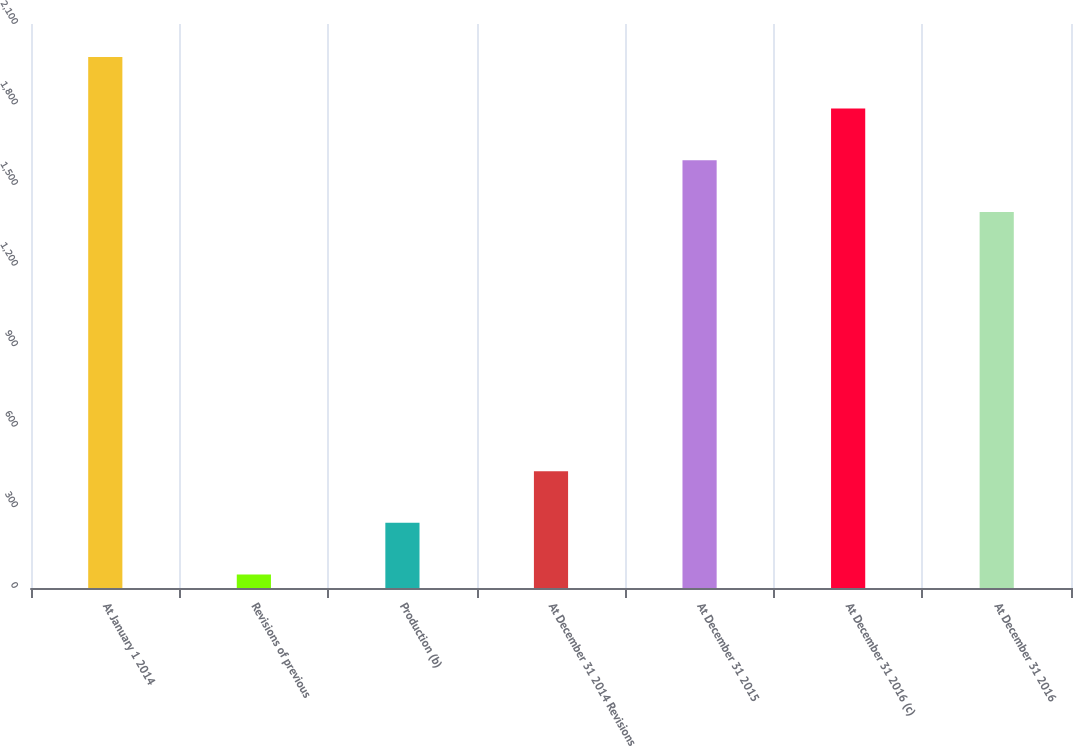Convert chart to OTSL. <chart><loc_0><loc_0><loc_500><loc_500><bar_chart><fcel>At January 1 2014<fcel>Revisions of previous<fcel>Production (b)<fcel>At December 31 2014 Revisions<fcel>At December 31 2015<fcel>At December 31 2016 (c)<fcel>At December 31 2016<nl><fcel>1977.5<fcel>50<fcel>242.5<fcel>435<fcel>1592.5<fcel>1785<fcel>1400<nl></chart> 